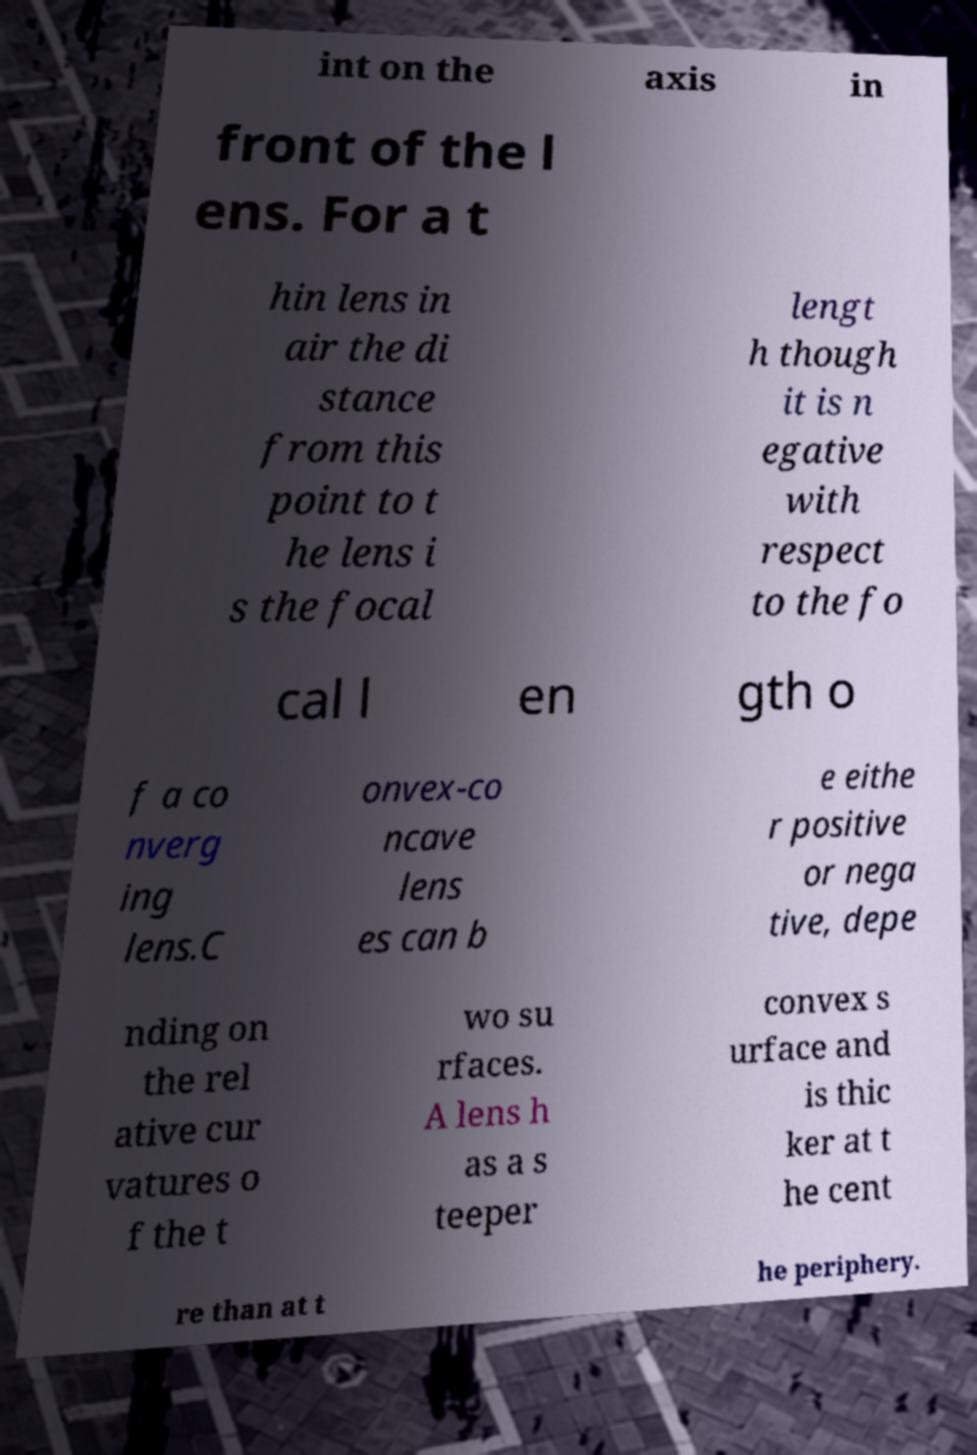Please read and relay the text visible in this image. What does it say? int on the axis in front of the l ens. For a t hin lens in air the di stance from this point to t he lens i s the focal lengt h though it is n egative with respect to the fo cal l en gth o f a co nverg ing lens.C onvex-co ncave lens es can b e eithe r positive or nega tive, depe nding on the rel ative cur vatures o f the t wo su rfaces. A lens h as a s teeper convex s urface and is thic ker at t he cent re than at t he periphery. 